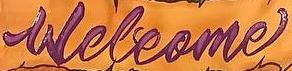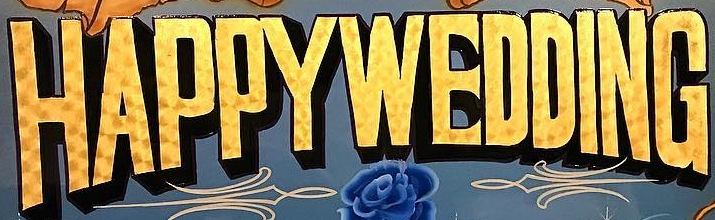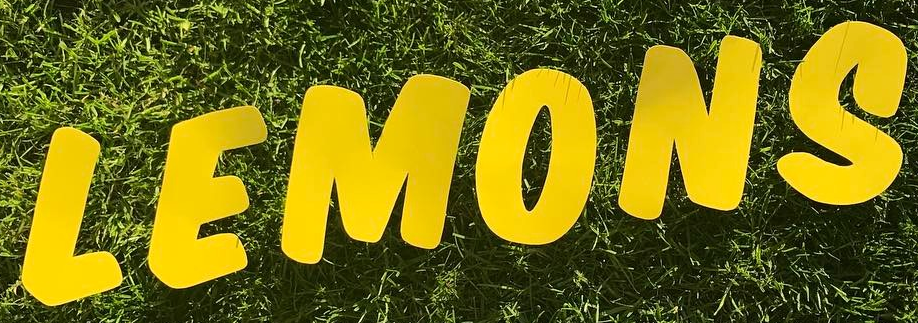Transcribe the words shown in these images in order, separated by a semicolon. Welcome; HAPPYWEDDING; LEMONS 